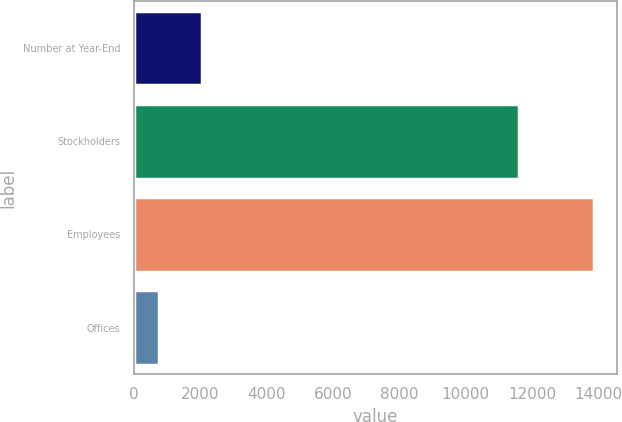Convert chart. <chart><loc_0><loc_0><loc_500><loc_500><bar_chart><fcel>Number at Year-End<fcel>Stockholders<fcel>Employees<fcel>Offices<nl><fcel>2070.9<fcel>11611<fcel>13869<fcel>760<nl></chart> 